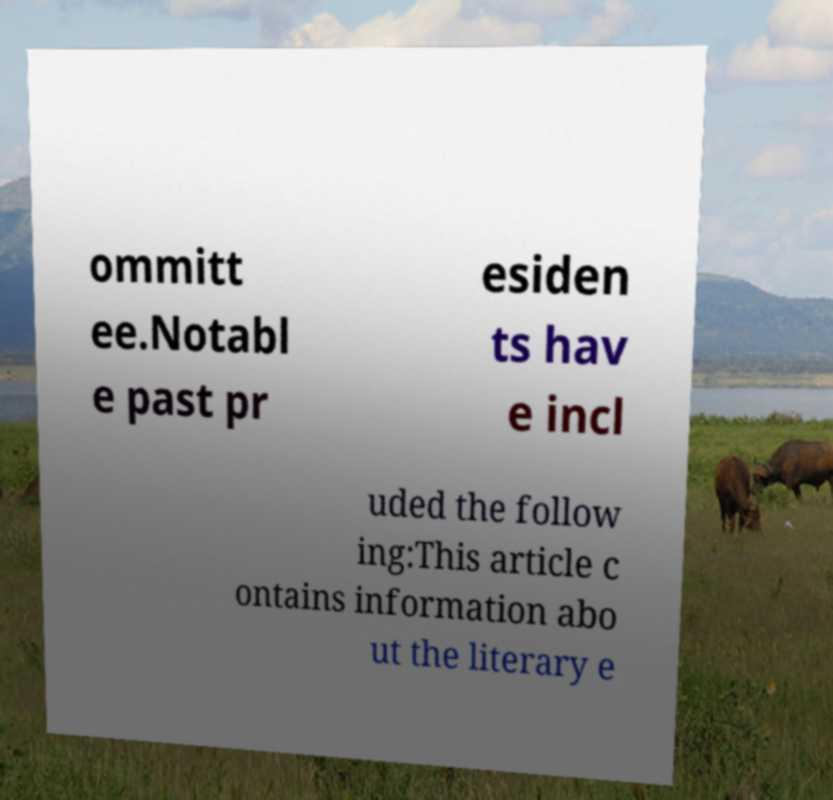What messages or text are displayed in this image? I need them in a readable, typed format. ommitt ee.Notabl e past pr esiden ts hav e incl uded the follow ing:This article c ontains information abo ut the literary e 